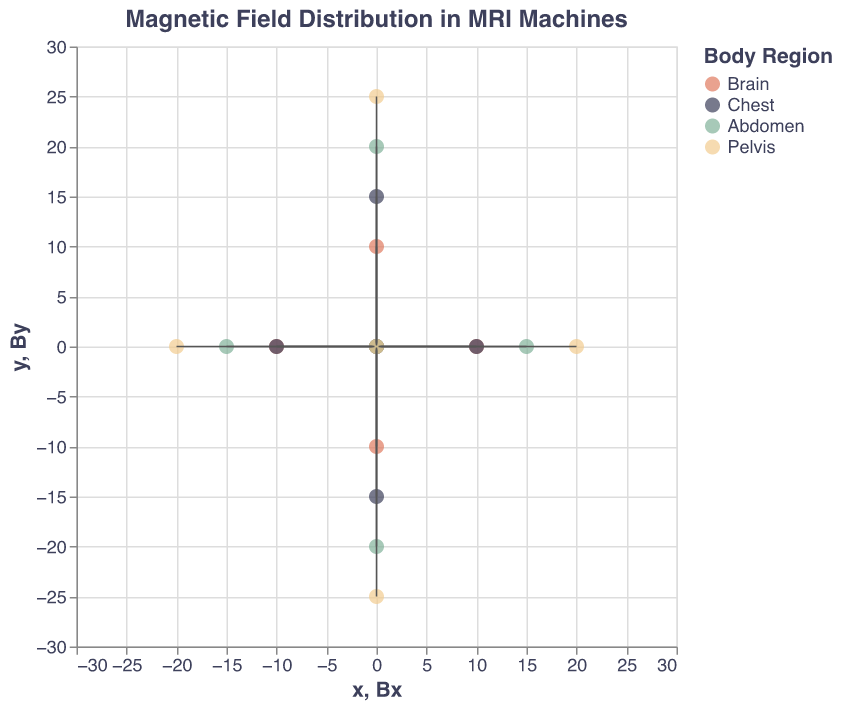What's the title of the figure? The title is located at the top center of the figure. It describes the overall content of the chart.
Answer: Magnetic Field Distribution in MRI Machines Which body region has the strongest magnetic field along the z-axis? By looking at the Bz values in the figure, the largest numeric value identified relates to the Brain region.
Answer: Brain How many data points represent the "Chest" region? By distinguishing the color for the Chest region in the legend and counting the corresponding points, you can identify the number of data points.
Answer: 5 What is the range of x-values shown in the plot? The x-axis shows the limits of the horizontal axis. By looking at the minimum and maximum x-values indicated on the axis, the range can be determined.
Answer: -30 to 30 What are the Bx and By values at (10, 0) in the Brain region? First, locate the data point for the coordinates (10, 0) in the Brain region using color as the identifier. Then check the attached vector values Bx and By.
Answer: Bx: 0.2, By: 0 Comparing the Chest and Abdomen regions, which has a higher average Bz value? Identify Bz values for all data points within both regions. Sum the values separately for each region and divide by the number of data points to find the averages. Chest Bz values: [2.5, 2.4, 2.4, 2.3, 2.3]; Abdomen Bz values: [2, 1.9, 1.9, 1.8, 1.8]. Calculate the averages: (2.5+2.4+2.4+2.3+2.3)/5 = 2.38; (2+1.9+1.9+1.8+1.8)/5 = 1.88. Chest's average Bz is higher.
Answer: Chest In which region and at which coordinate do you find the magnetic field vector (0, -0.2) for Bz = 2.3? Look for the given (0, -0.2) vector value and match it with the corresponding Bz value (2.3) and record the region and coordinates.
Answer: Chest at (0, -15, 50) What is the magnetic field strength along the x-axis in the Pelvis region at (20, 0)? Locate the data point at (20, 0) in the Pelvis region, check the Bx component of the vector originating from this point.
Answer: 0.5 Which regions have opposing direction vectors on the x-axis at the same coordinates? Compare data points with equal x and y coordinates among different regions. Identify if their Bx components have opposite signs. Example: Brain at (10, 0) Bx: 0.2, Chest at (10, 0) Bx: 0.3. This does not match, but (20, 0) in Pelvis Bx: 0.5 and (-20, 0) in Pelvis Bx: -0.5 shows opposite Bx for the same region's different points.
Answer: Pelvis At what z-coordinate does the magnetic field strength along the z-axis decrease below 2.0? Check the Bz values on the figure for each data point and their z-coordinates. Identify when the Bz value first falls below 2.0.
Answer: 100 What's the difference in Bz value between the Brain and Pelvis regions? Calculate the difference between the average of Bz values of Brain and Pelvis regions. Brain Bz: [3, 2.9, 2.9, 2.8, 2.8]; Pelvis Bz: [1.5, 1.4, 1.4, 1.3, 1.3]. Find their averages: Brain: (3+2.9+2.9+2.8+2.8)/5 = 2.88; Pelvis: (1.5+1.4+1.4+1.3+1.3)/5 = 1.38. The difference is: 2.88 - 1.38.
Answer: 1.5 